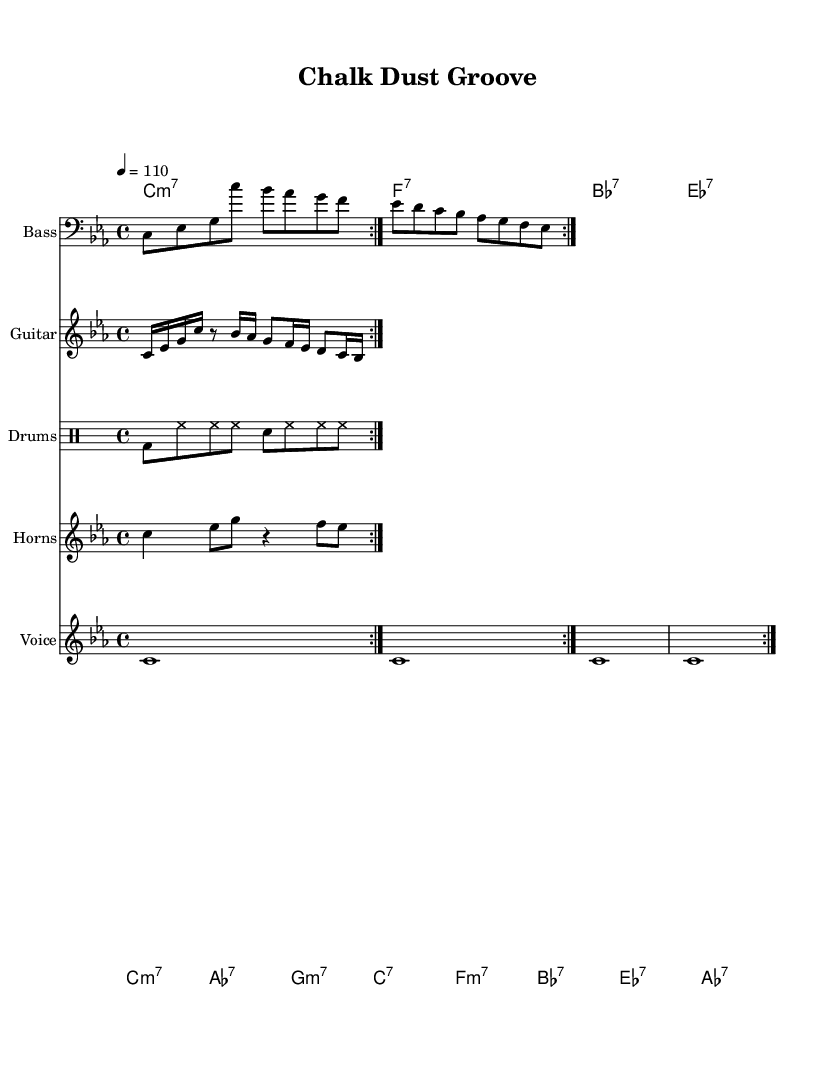What is the key signature of this music? The key signature is C minor, which has three flats (B flat, E flat, and A flat). This is indicated at the beginning of the sheet music where the key signature is displayed.
Answer: C minor What is the time signature of the piece? The time signature is displayed at the beginning of the sheet music as 4/4, which indicates that there are four beats in each measure and the quarter note gets one beat.
Answer: 4/4 What is the tempo marking for this music? The tempo is set at 110 beats per minute, indicated by "4 = 110" at the top of the score. This means that the quarter note should be played at a speed of 110 beats per minute.
Answer: 110 How many measures are there in the bass line? To find the number of measures in the bass line, we look at the bass line notation which consists of a total of 8 beats if it repeats twice, resulting in 2 measures.
Answer: 2 What chord is played in the chorus? The chorus consists of four chords: C minor 7, A flat 7, G minor 7, and C 7. The first chord is C minor 7, which is the starting point for this section.
Answer: C minor 7 What is a characteristic rhythmic element found in the drum pattern? The drum pattern features a steady hi-hat rhythm, which is common in funk music, and supports the syncopated feel by playing consistently throughout the measures, contrasting with the bass and snare hits.
Answer: Consistent hi-hat What instrumental section plays a riff in this piece? The riff is specifically played by the guitar section as indicated in the staff labeled "Guitar." The guitar riff enhances the funky feel of the music through its rhythmic and melodic contributions.
Answer: Guitar 